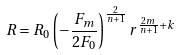<formula> <loc_0><loc_0><loc_500><loc_500>R = R _ { 0 } \left ( - \frac { F _ { m } } { 2 F _ { 0 } } \right ) ^ { \frac { 2 } { n + 1 } } r ^ { \frac { 2 m } { n + 1 } + k }</formula> 